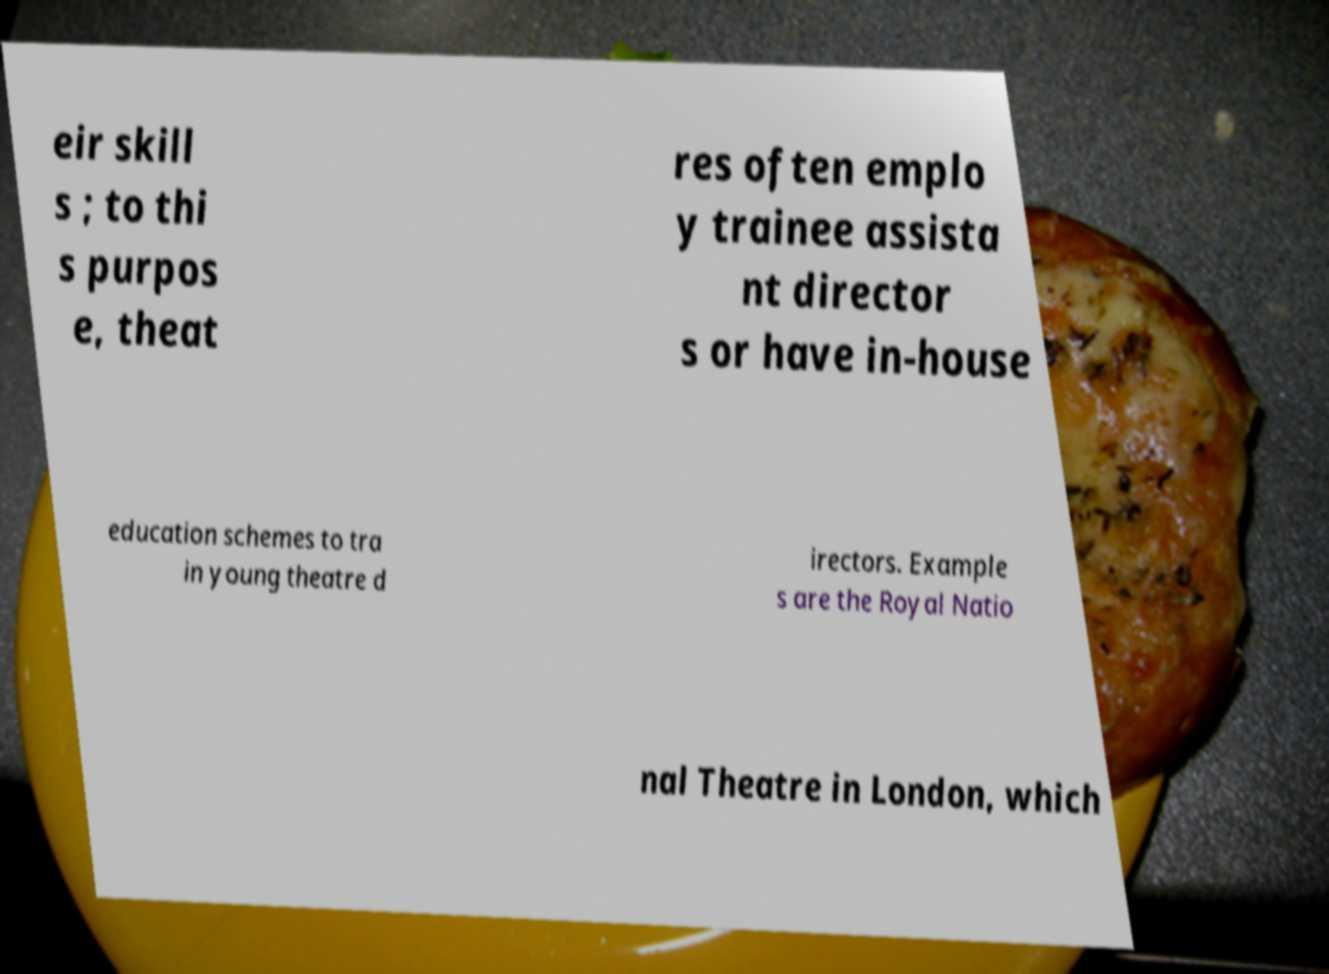Could you assist in decoding the text presented in this image and type it out clearly? eir skill s ; to thi s purpos e, theat res often emplo y trainee assista nt director s or have in-house education schemes to tra in young theatre d irectors. Example s are the Royal Natio nal Theatre in London, which 